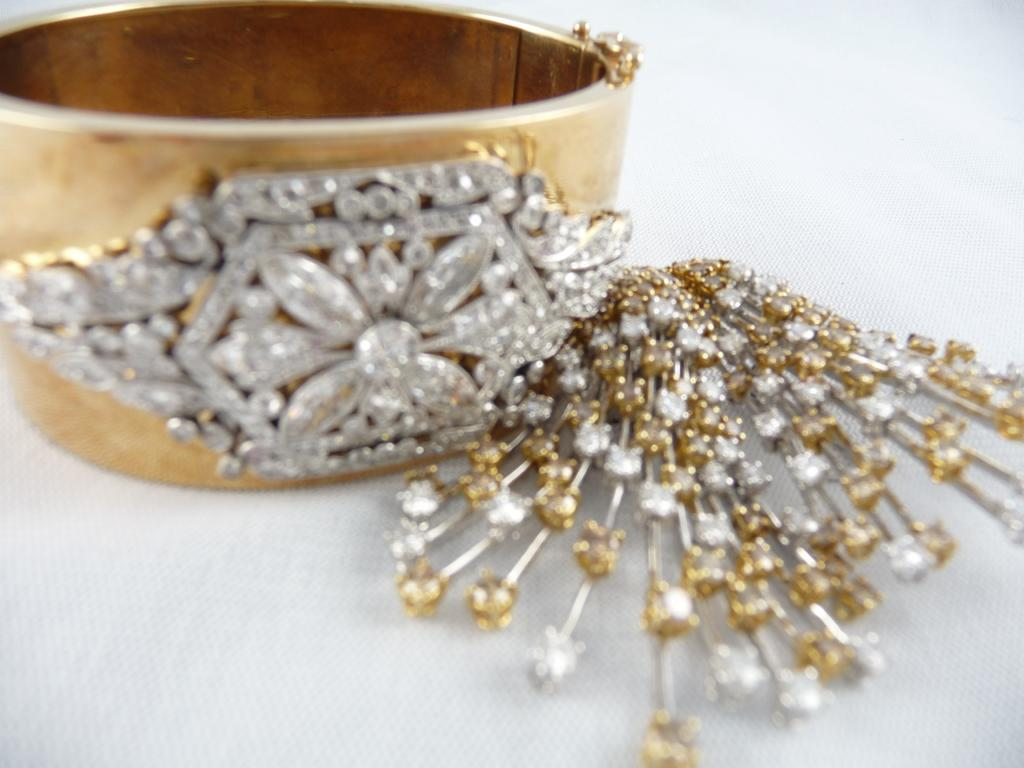What type of jewelry is featured in the image? There is a bangle in the image. What are the decorative elements on the bangle? The bangle has stones. On what surface is the bangle placed in the image? The bangle is on a white surface. What type of humor can be seen in the image? There is no humor present in the image; it features a bangle with stones on a white surface. 